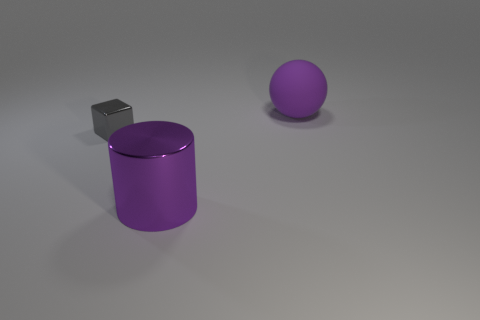Add 1 large purple metallic objects. How many objects exist? 4 Subtract all balls. How many objects are left? 2 Add 3 matte balls. How many matte balls are left? 4 Add 1 yellow balls. How many yellow balls exist? 1 Subtract 0 brown blocks. How many objects are left? 3 Subtract all big shiny things. Subtract all purple cylinders. How many objects are left? 1 